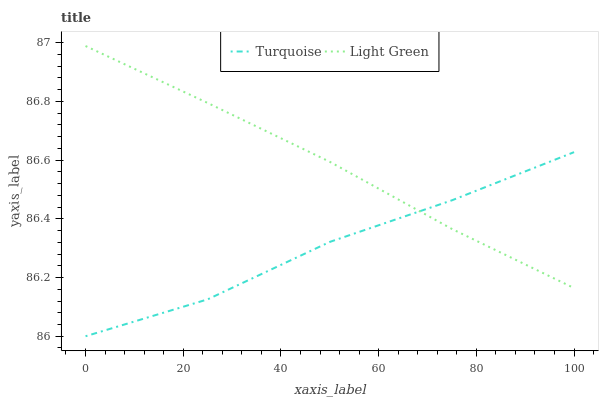Does Turquoise have the minimum area under the curve?
Answer yes or no. Yes. Does Light Green have the maximum area under the curve?
Answer yes or no. Yes. Does Light Green have the minimum area under the curve?
Answer yes or no. No. Is Light Green the smoothest?
Answer yes or no. Yes. Is Turquoise the roughest?
Answer yes or no. Yes. Is Light Green the roughest?
Answer yes or no. No. Does Light Green have the lowest value?
Answer yes or no. No. 